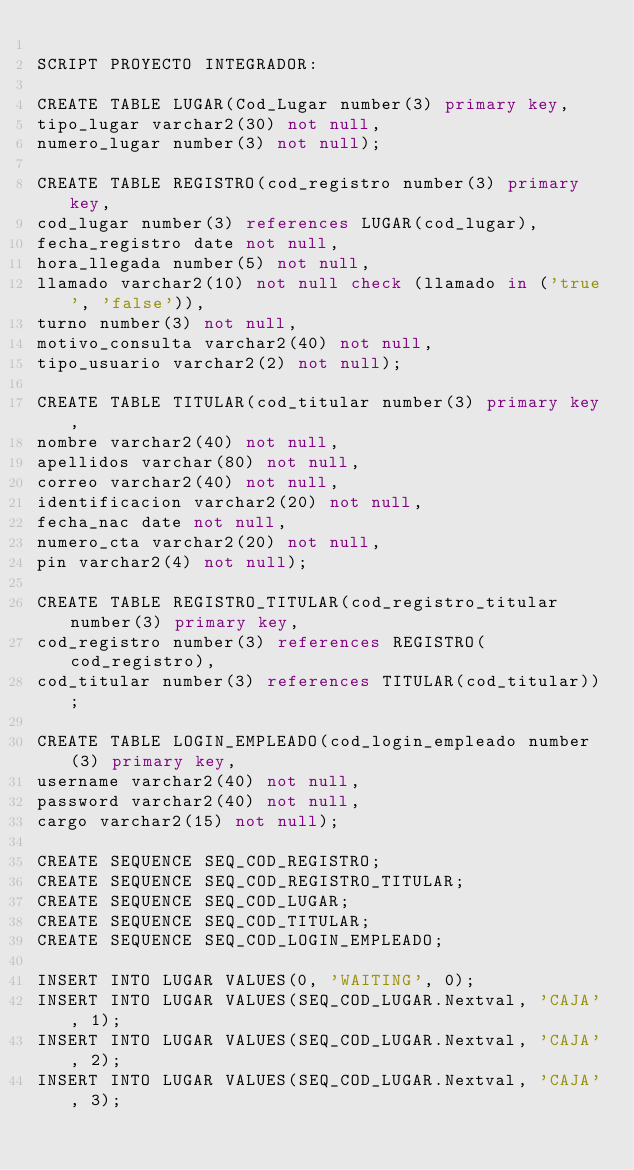<code> <loc_0><loc_0><loc_500><loc_500><_SQL_>
SCRIPT PROYECTO INTEGRADOR:

CREATE TABLE LUGAR(Cod_Lugar number(3) primary key,
tipo_lugar varchar2(30) not null,
numero_lugar number(3) not null);

CREATE TABLE REGISTRO(cod_registro number(3) primary key,
cod_lugar number(3) references LUGAR(cod_lugar),
fecha_registro date not null,
hora_llegada number(5) not null,
llamado varchar2(10) not null check (llamado in ('true', 'false')),
turno number(3) not null,
motivo_consulta varchar2(40) not null,
tipo_usuario varchar2(2) not null);

CREATE TABLE TITULAR(cod_titular number(3) primary key,
nombre varchar2(40) not null,
apellidos varchar(80) not null,
correo varchar2(40) not null,
identificacion varchar2(20) not null,
fecha_nac date not null,
numero_cta varchar2(20) not null,
pin varchar2(4) not null);

CREATE TABLE REGISTRO_TITULAR(cod_registro_titular number(3) primary key,
cod_registro number(3) references REGISTRO(cod_registro),
cod_titular number(3) references TITULAR(cod_titular));

CREATE TABLE LOGIN_EMPLEADO(cod_login_empleado number(3) primary key,
username varchar2(40) not null,
password varchar2(40) not null,
cargo varchar2(15) not null);
 
CREATE SEQUENCE SEQ_COD_REGISTRO;
CREATE SEQUENCE SEQ_COD_REGISTRO_TITULAR;
CREATE SEQUENCE SEQ_COD_LUGAR; 
CREATE SEQUENCE SEQ_COD_TITULAR;
CREATE SEQUENCE SEQ_COD_LOGIN_EMPLEADO;

INSERT INTO LUGAR VALUES(0, 'WAITING', 0);
INSERT INTO LUGAR VALUES(SEQ_COD_LUGAR.Nextval, 'CAJA', 1);
INSERT INTO LUGAR VALUES(SEQ_COD_LUGAR.Nextval, 'CAJA', 2);
INSERT INTO LUGAR VALUES(SEQ_COD_LUGAR.Nextval, 'CAJA', 3);</code> 